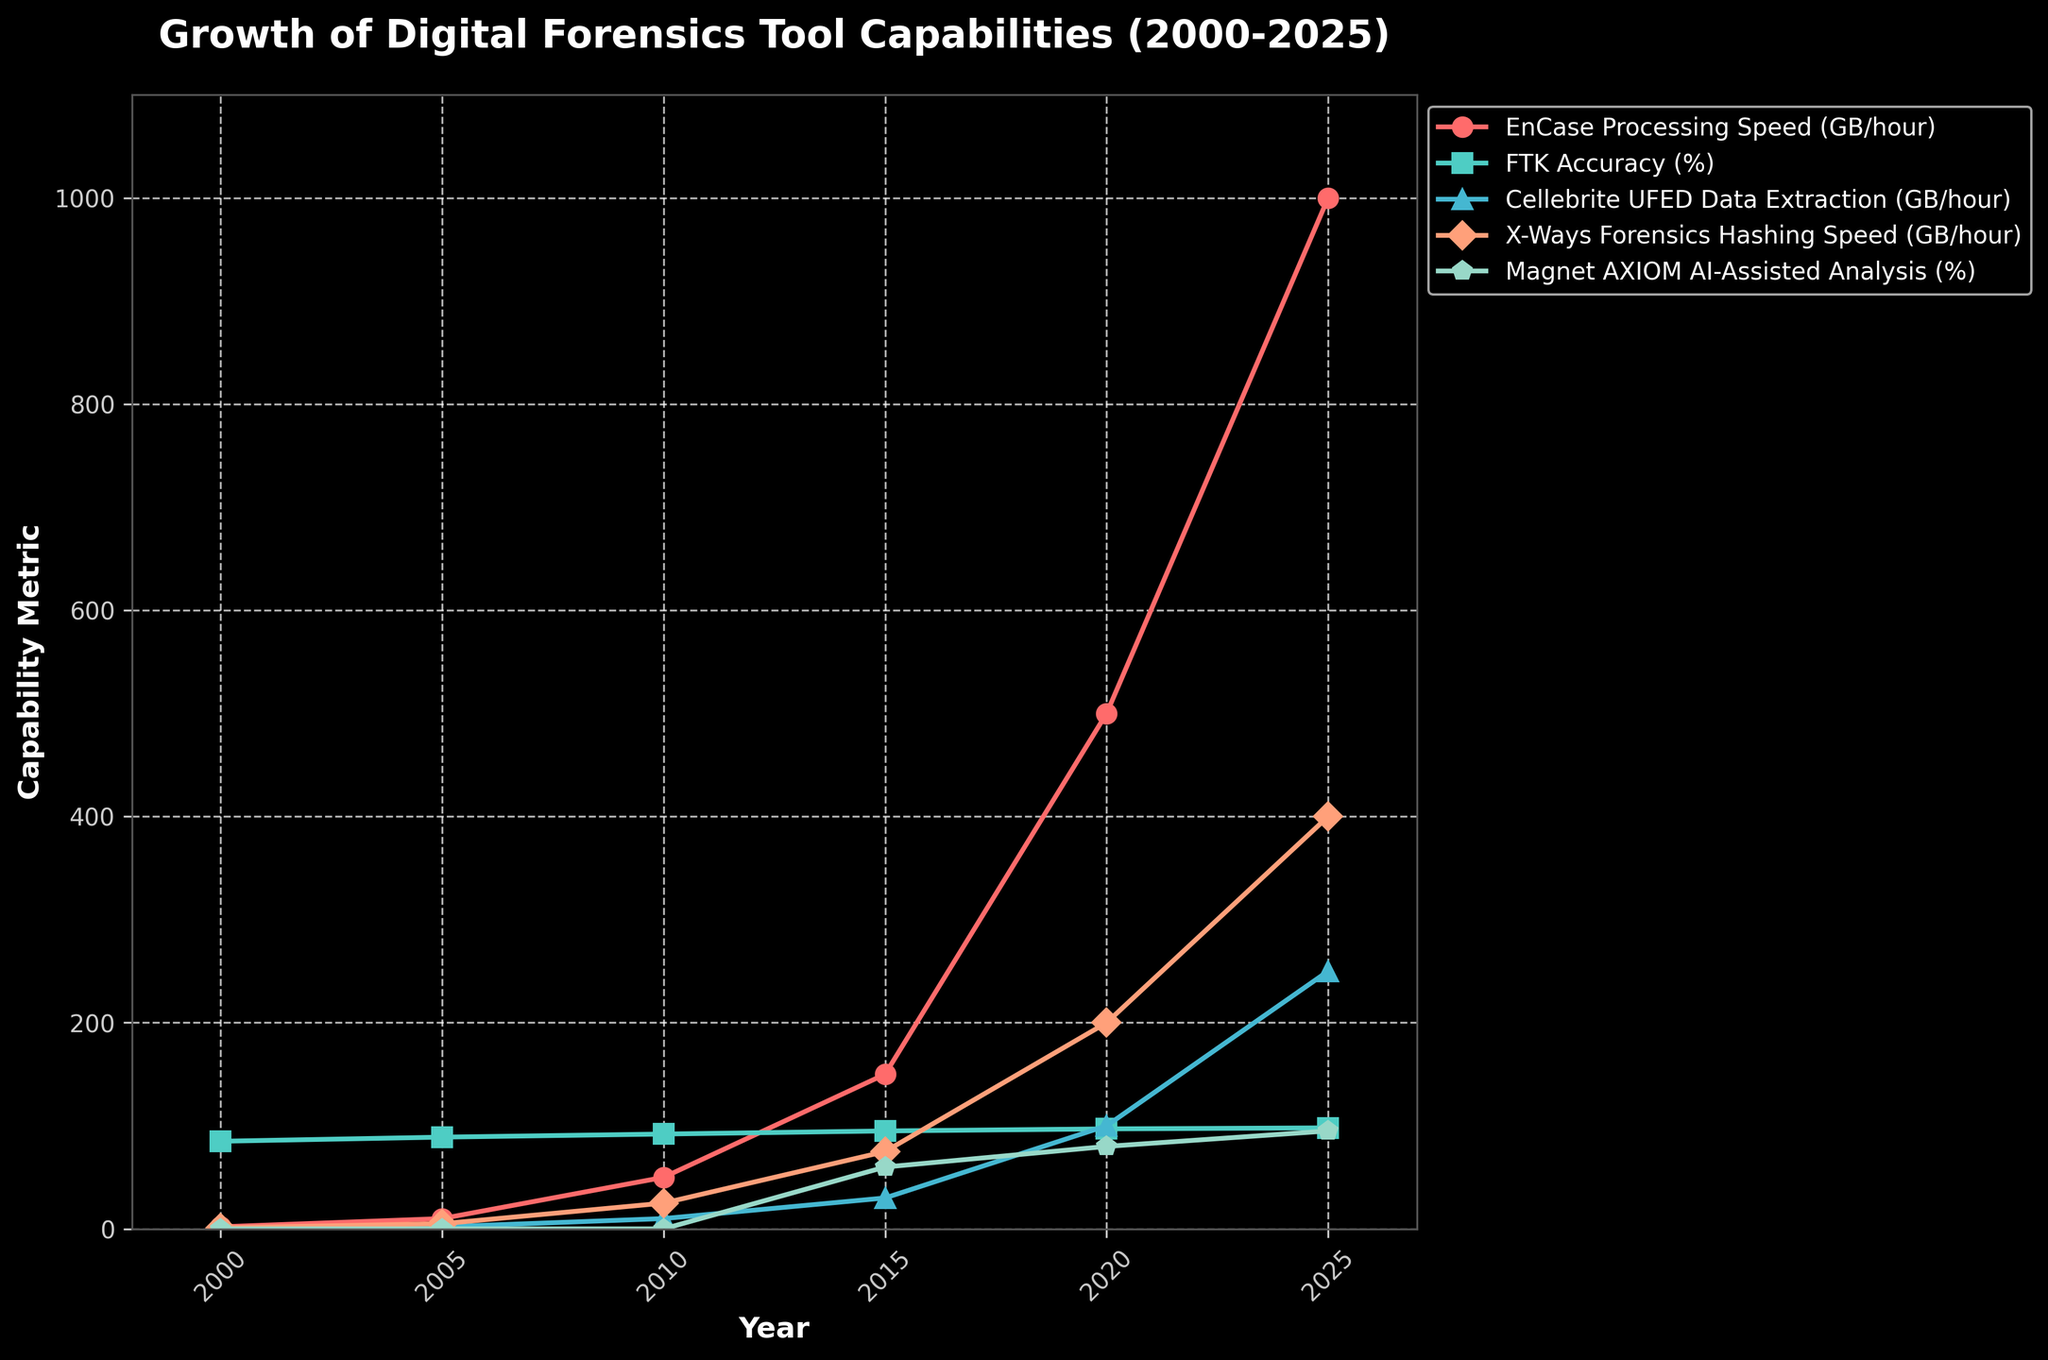What is the trend in EnCase Processing Speed from 2000 to 2025? The trend shows a consistent increase over the years. Starting from 2 GB/hour in 2000, it rises to 10 GB/hour in 2005, then to 50 GB/hour in 2010, 150 GB/hour in 2015, 500 GB/hour in 2020, and finally reaching 1000 GB/hour in 2025.
Answer: Increasing How does FTK Accuracy change between 2000 and 2025? FTK Accuracy improves continuously from 85% in 2000 to 89% in 2005, 92% in 2010, 95% in 2015, 97% in 2020, and achieves 98% by 2025.
Answer: Increasing Which tool shows the most significant growth in terms of data processing speed from 2000 to 2025? Comparing the growth in data processing speed, EnCase shows the most significant growth, from 2 GB/hour in 2000 to 1000 GB/hour in 2025.
Answer: EnCase What is the data extraction speed of Cellebrite UFED in 2015, and how does it compare to that in 2020? In 2015, the data extraction speed of Cellebrite UFED is 30 GB/hour, while in 2020, it increases to 100 GB/hour. The speed more than triples over these 5 years.
Answer: 30 GB/hour in 2015, 100 GB/hour in 2020 Between 2005 and 2015, which tool shows the highest increase in their capability metric? Comparing the increments, EnCase increases from 10 GB/hour to 150 GB/hour (140 GB/hour increase), FTK Accuracy increases from 89% to 95% (6% increase), Cellebrite UFED increases from 2 GB/hour to 30 GB/hour (28 GB/hour increase), X-Ways Forensics increases from 5 GB/hour to 75 GB/hour (70 GB/hour increase), and Magnet AXIOM AI-assisted analysis from 0% to 60% (60% increase). EnCase shows the highest increase.
Answer: EnCase What is the color of the line representing X-Ways Forensics Hashing Speed? The line representing X-Ways Forensics Hashing Speed is red.
Answer: Red By what percentage does Magnet AXIOM's AI-Assisted Analysis accuracy improve from 2015 to 2025? Magnet AXIOM's AI-Assisted Analysis accuracy improves from 60% in 2015 to 95% in 2025. The improvement is calculated as (95-60)/60 * 100 = 58.33%.
Answer: 58.33% Which tool has the highest capability metric in 2025, and what is its value? In 2025, EnCase Processing Speed has the highest capability metric with a value of 1000 GB/hour.
Answer: EnCase, 1000 GB/hour How much faster is the EnCase Processing Speed in 2025 compared to 2000? The EnCase Processing Speed in 2025 is 1000 GB/hour, and in 2000 it was 2 GB/hour. The difference is 1000 - 2 = 998 GB/hour.
Answer: 998 GB/hour Which year shows significant improvements in multiple tools' capabilities compared to their previous intervals? The year 2015 shows significant improvements: EnCase (150 GB/hour), FTK (95%), Cellebrite (30 GB/hour), X-Ways (75 GB/hour), and Magnet AXIOM (60%) all show considerable growth compared to 2010.
Answer: 2015 